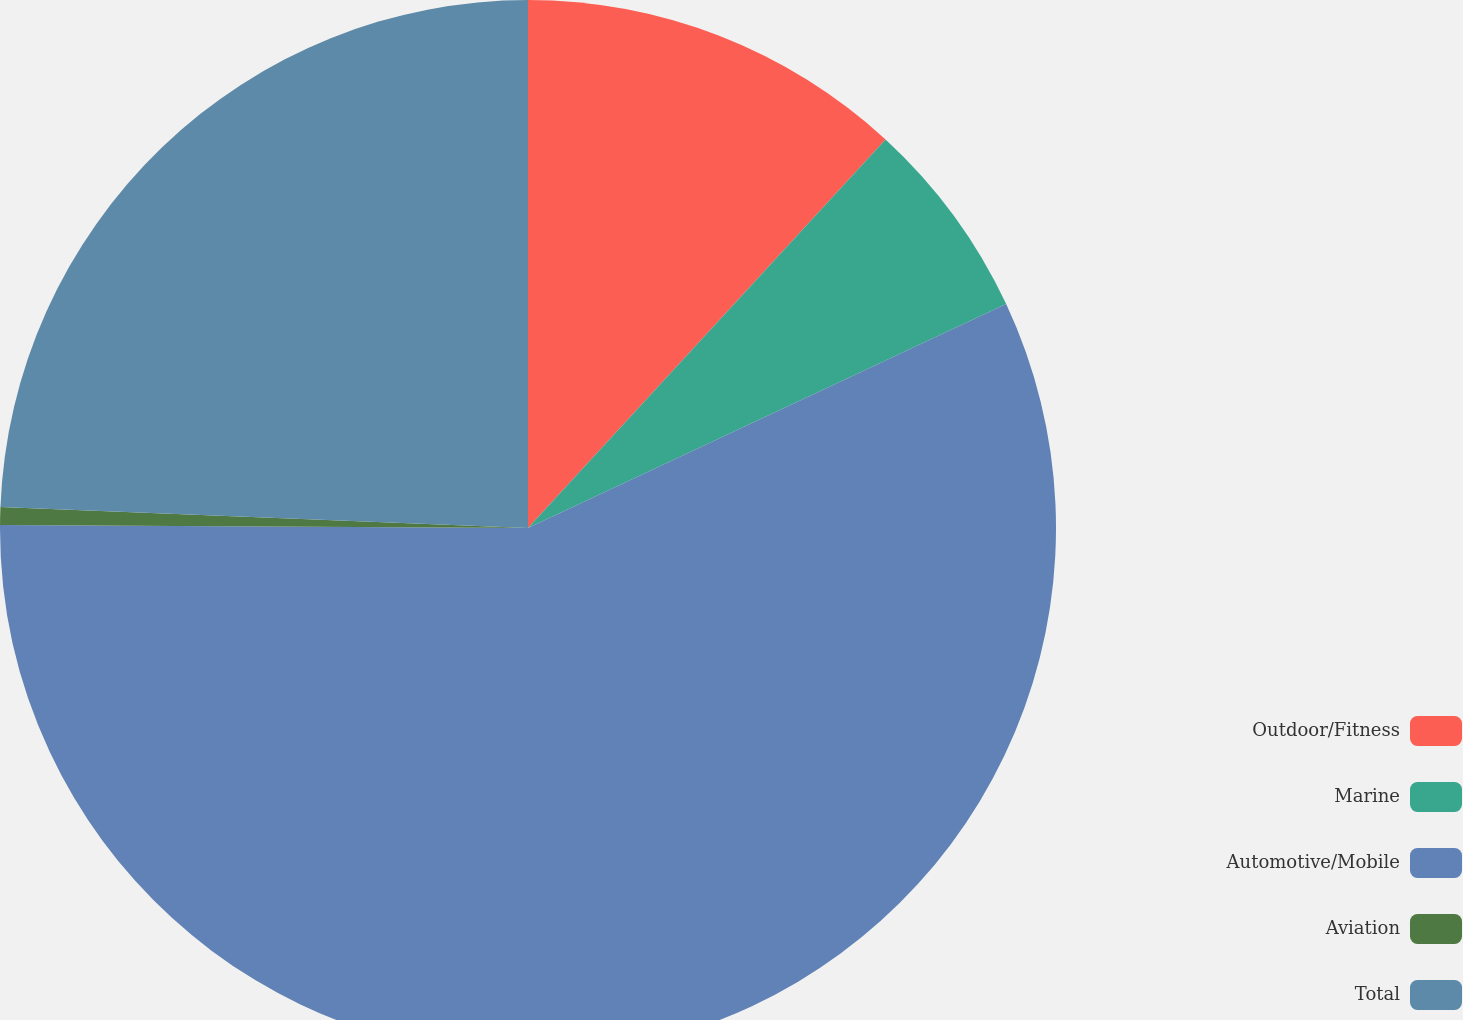Convert chart. <chart><loc_0><loc_0><loc_500><loc_500><pie_chart><fcel>Outdoor/Fitness<fcel>Marine<fcel>Automotive/Mobile<fcel>Aviation<fcel>Total<nl><fcel>11.84%<fcel>6.19%<fcel>57.06%<fcel>0.54%<fcel>24.37%<nl></chart> 